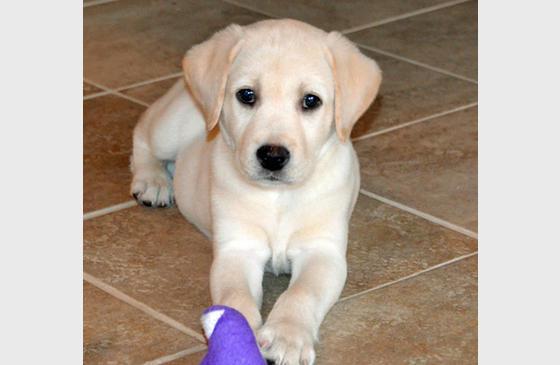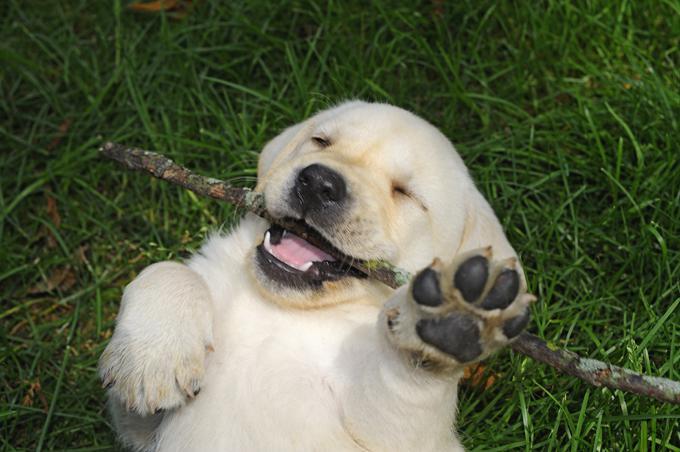The first image is the image on the left, the second image is the image on the right. Examine the images to the left and right. Is the description "There are no less than four dogs" accurate? Answer yes or no. No. 